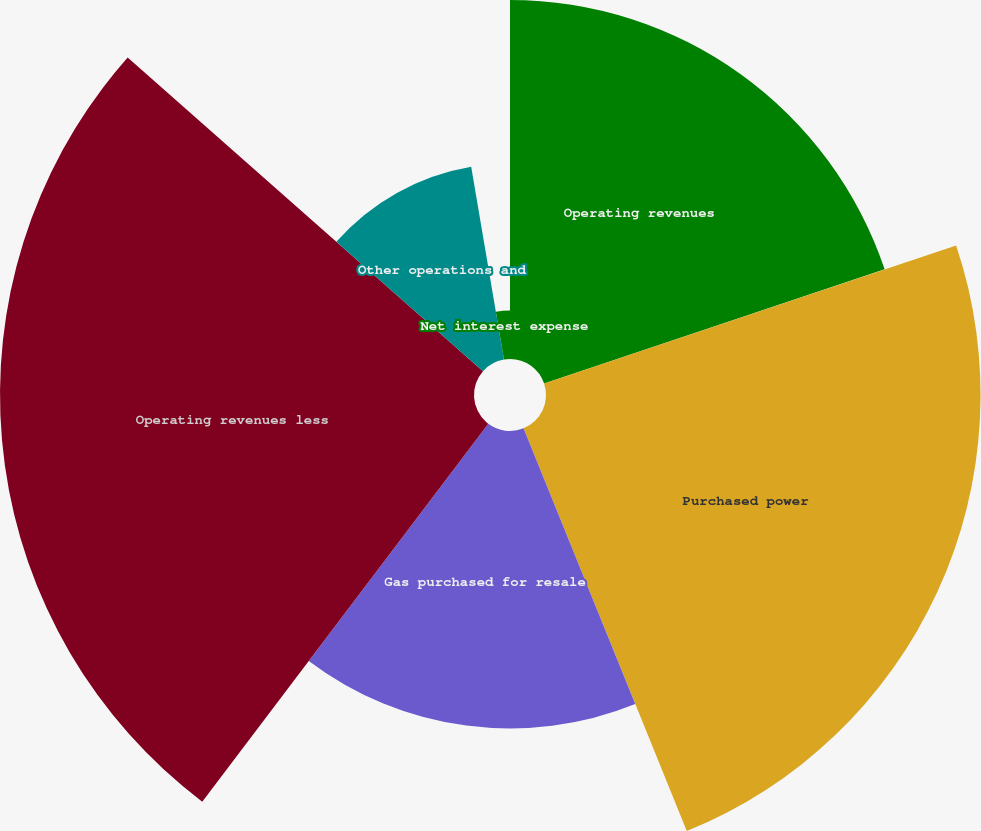<chart> <loc_0><loc_0><loc_500><loc_500><pie_chart><fcel>Operating revenues<fcel>Purchased power<fcel>Gas purchased for resale<fcel>Operating revenues less<fcel>Other operations and<fcel>Net interest expense<nl><fcel>19.85%<fcel>24.02%<fcel>16.44%<fcel>26.2%<fcel>10.81%<fcel>2.68%<nl></chart> 